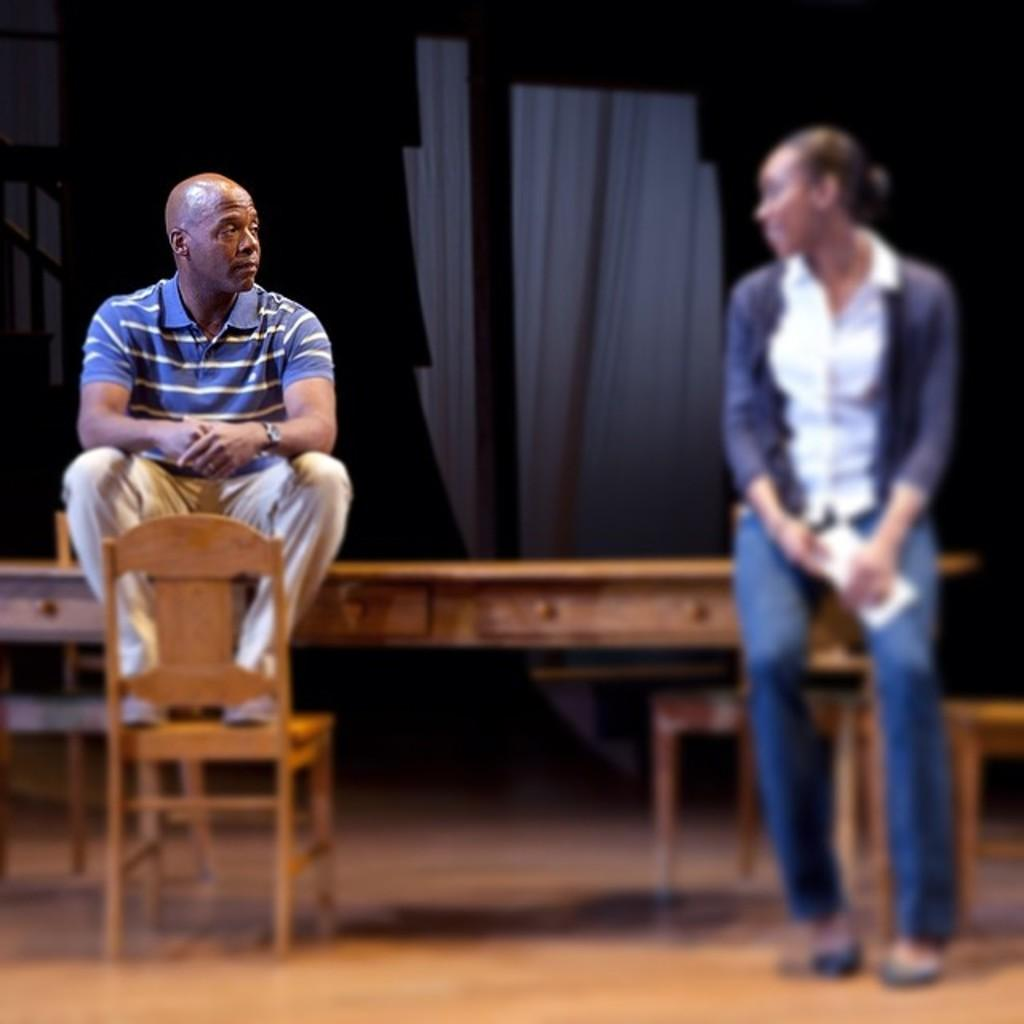How many people are present in the image? There are two people in the image. What are the two people doing in the image? The two people are sitting on a table. What type of soap is the spy using in the image? There is no soap, spy, or any activity involving soap in the image. 